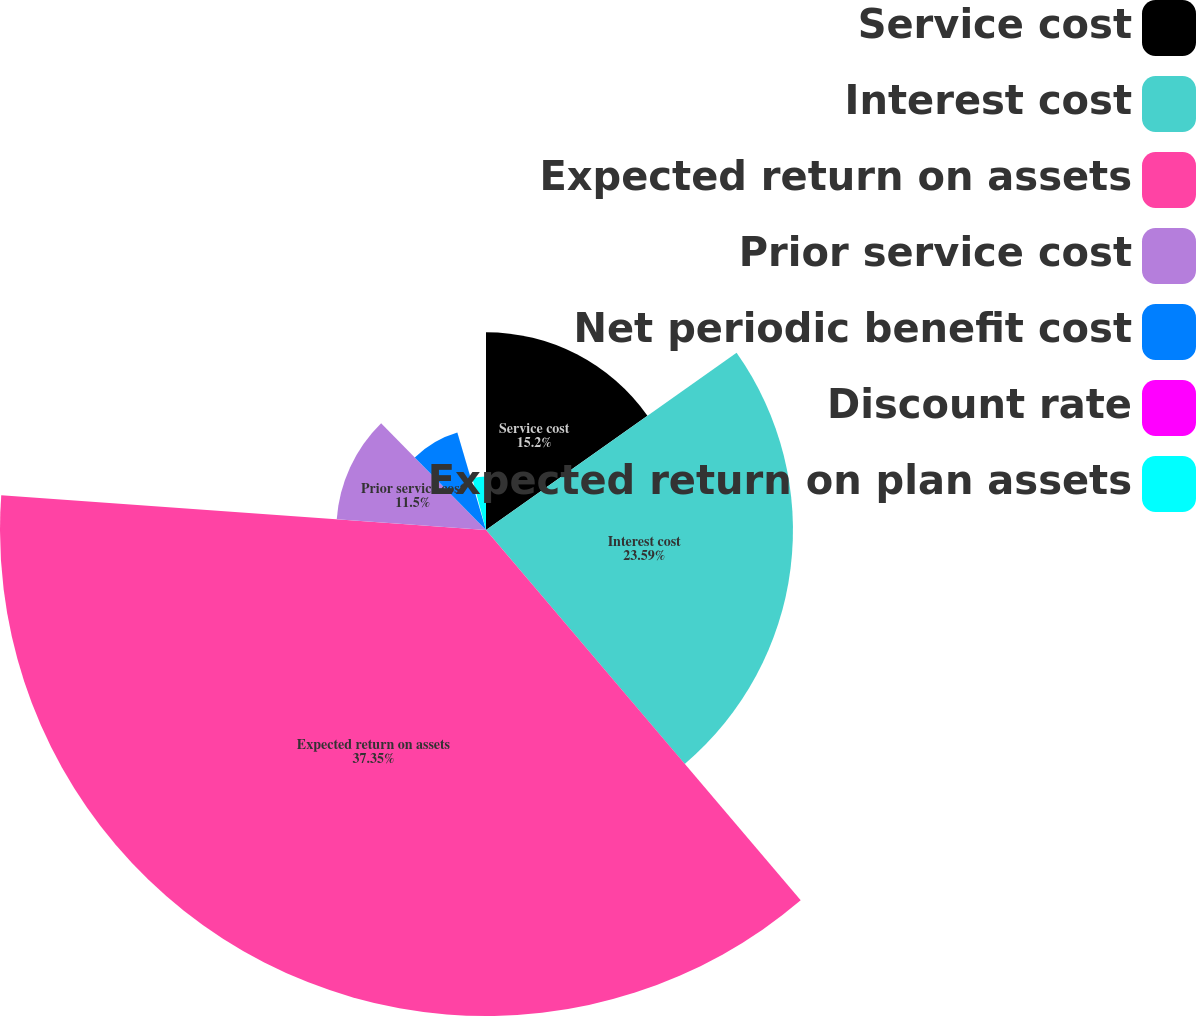Convert chart to OTSL. <chart><loc_0><loc_0><loc_500><loc_500><pie_chart><fcel>Service cost<fcel>Interest cost<fcel>Expected return on assets<fcel>Prior service cost<fcel>Net periodic benefit cost<fcel>Discount rate<fcel>Expected return on plan assets<nl><fcel>15.2%<fcel>23.59%<fcel>37.35%<fcel>11.5%<fcel>7.81%<fcel>0.43%<fcel>4.12%<nl></chart> 